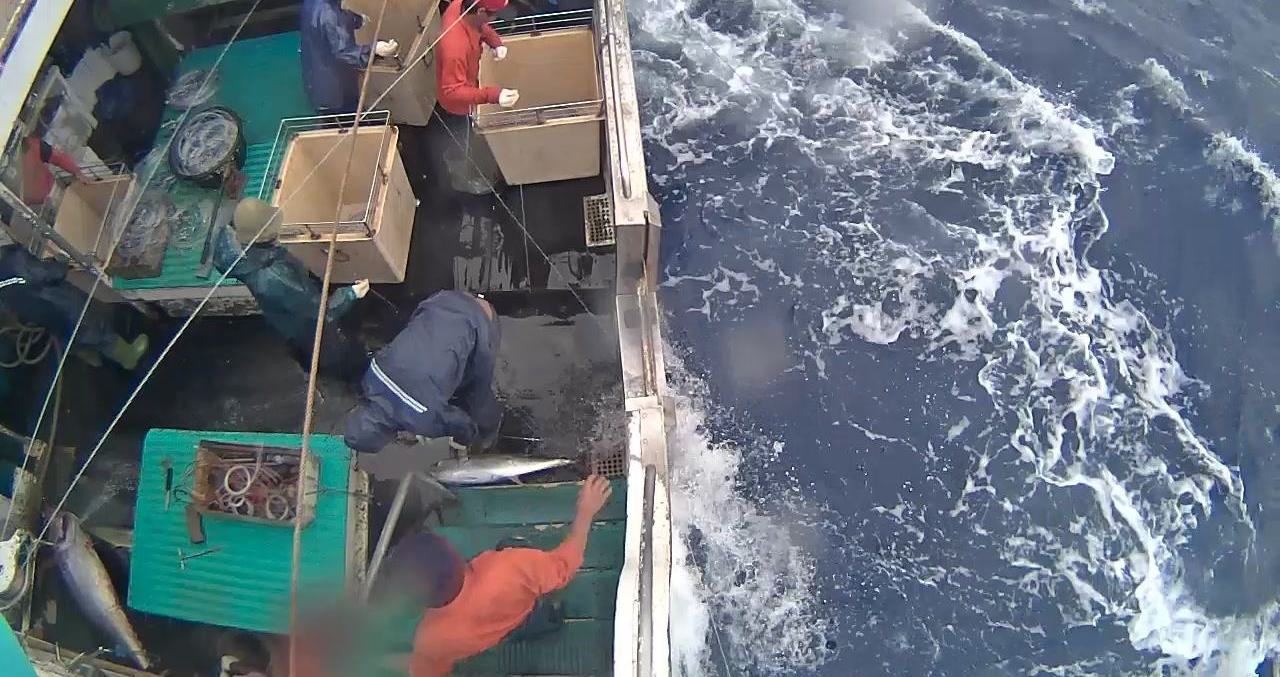Describe the image in detail This image appears to be taken from a fishing boat or vessel out at sea. The deck is cluttered with various equipment and supplies like boxes, crates, and fishing gear. Two individuals are visible, one wearing a red jacket and another wearing gray, both working on the deck. The most striking feature is the view of the churning ocean water right alongside the boat, with white foamy waves and swirls visible against the deep blue color of the sea. The perspective gives a sense of being up close to the powerful motion and force of the open water as the vessel cuts through the waves. 